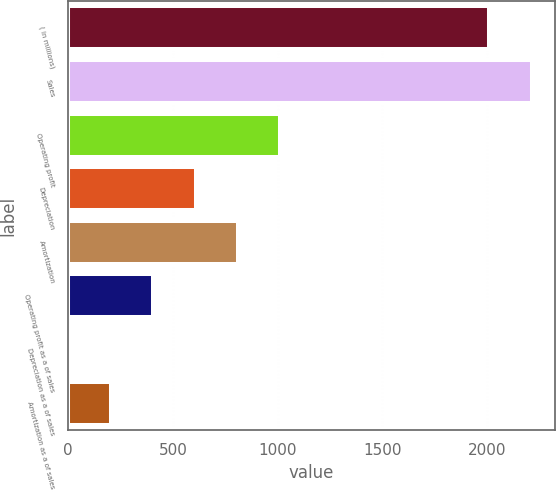<chart> <loc_0><loc_0><loc_500><loc_500><bar_chart><fcel>( in millions)<fcel>Sales<fcel>Operating profit<fcel>Depreciation<fcel>Amortization<fcel>Operating profit as a of sales<fcel>Depreciation as a of sales<fcel>Amortization as a of sales<nl><fcel>2012<fcel>2214.11<fcel>1012.35<fcel>608.13<fcel>810.24<fcel>406.02<fcel>1.8<fcel>203.91<nl></chart> 